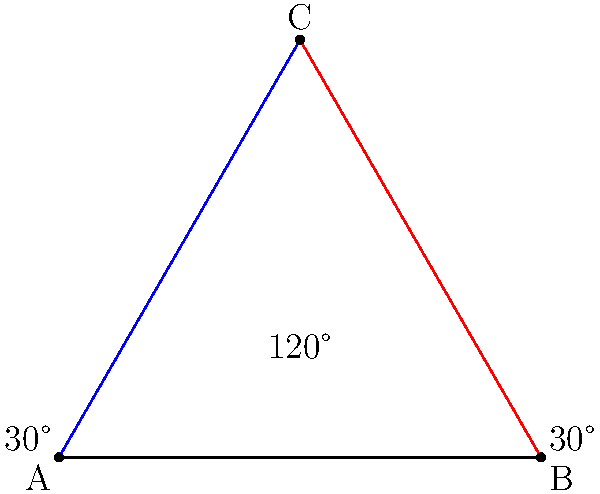You're tuning your guitar and notice that two strings intersect at a 120° angle. If these strings form two equal angles with the guitar's body, what is the measure of each of these equal angles? Let's approach this step-by-step:

1) First, let's visualize the scenario. The two intersecting guitar strings form a triangle with the guitar's body.

2) We're given that the angle between the strings is 120°. Let's call this angle C.

3) The question states that the strings form two equal angles with the guitar's body. Let's call these angles A and B.

4) In any triangle, the sum of all interior angles is always 180°. So we can write:

   $A + B + C = 180°$

5) We know that C = 120°, so:

   $A + B + 120° = 180°$

6) We're also told that A and B are equal. Let's call their measure x. So:

   $x + x + 120° = 180°$
   $2x + 120° = 180°$

7) Solving for x:

   $2x = 180° - 120° = 60°$
   $x = 60° ÷ 2 = 30°$

Therefore, each of the equal angles formed by the strings with the guitar's body measures 30°.
Answer: 30° 